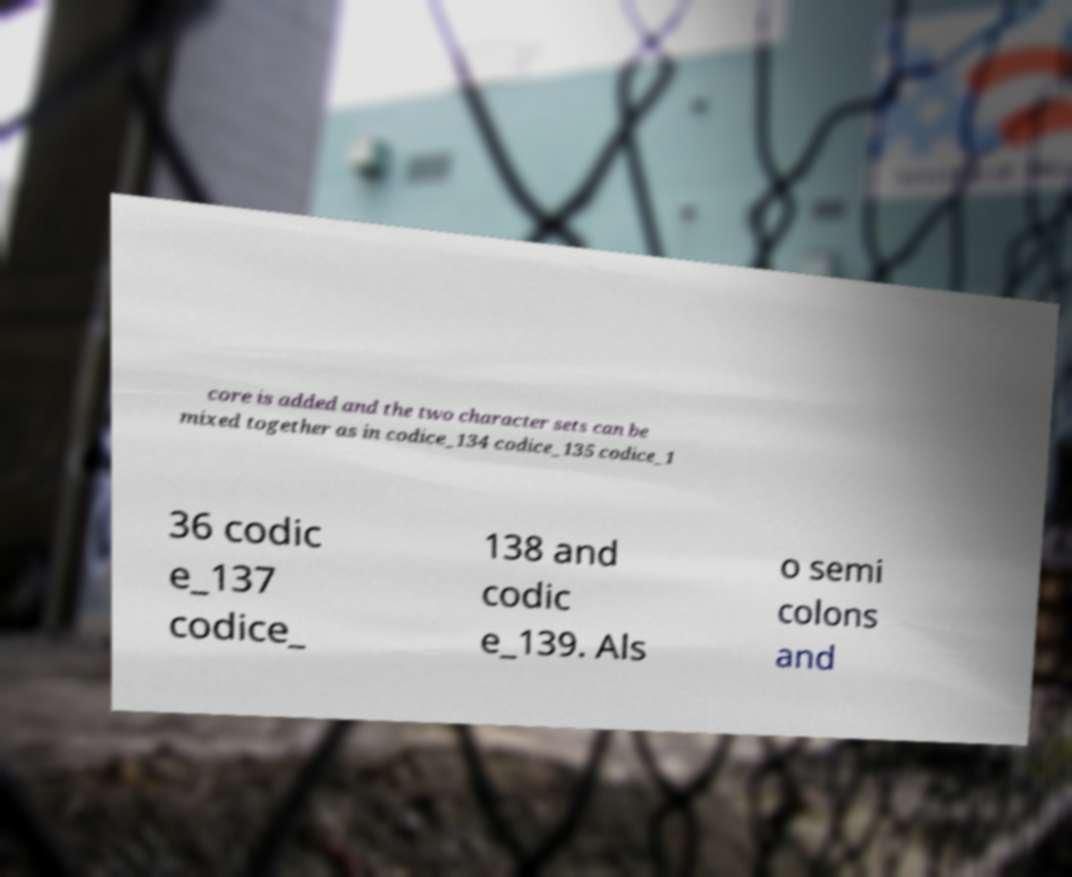Could you extract and type out the text from this image? core is added and the two character sets can be mixed together as in codice_134 codice_135 codice_1 36 codic e_137 codice_ 138 and codic e_139. Als o semi colons and 